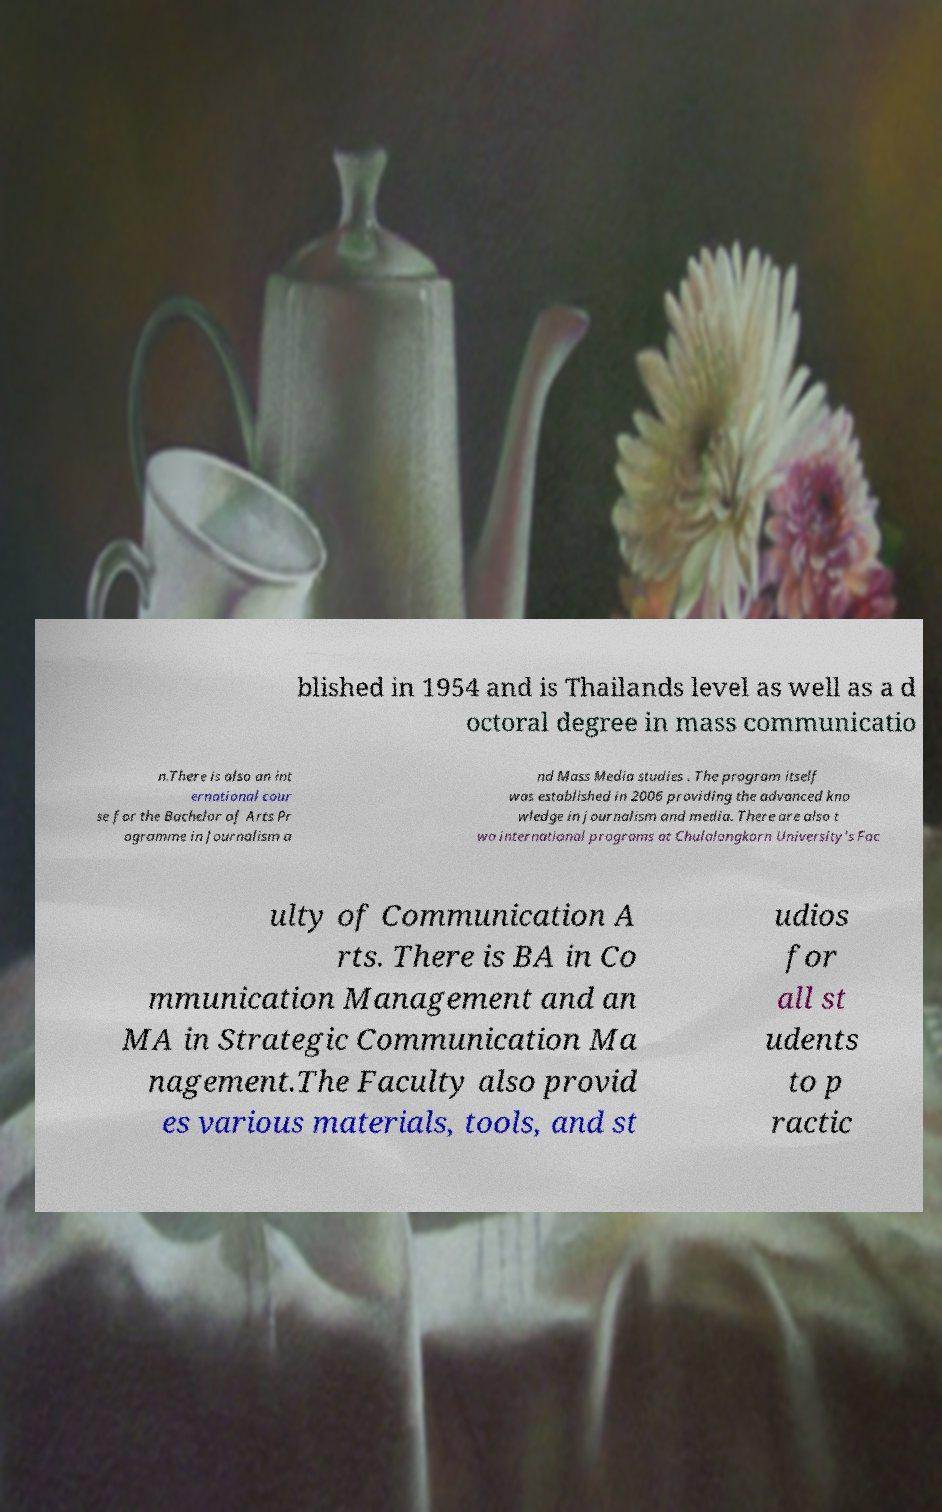Can you read and provide the text displayed in the image?This photo seems to have some interesting text. Can you extract and type it out for me? blished in 1954 and is Thailands level as well as a d octoral degree in mass communicatio n.There is also an int ernational cour se for the Bachelor of Arts Pr ogramme in Journalism a nd Mass Media studies . The program itself was established in 2006 providing the advanced kno wledge in journalism and media. There are also t wo international programs at Chulalongkorn University's Fac ulty of Communication A rts. There is BA in Co mmunication Management and an MA in Strategic Communication Ma nagement.The Faculty also provid es various materials, tools, and st udios for all st udents to p ractic 